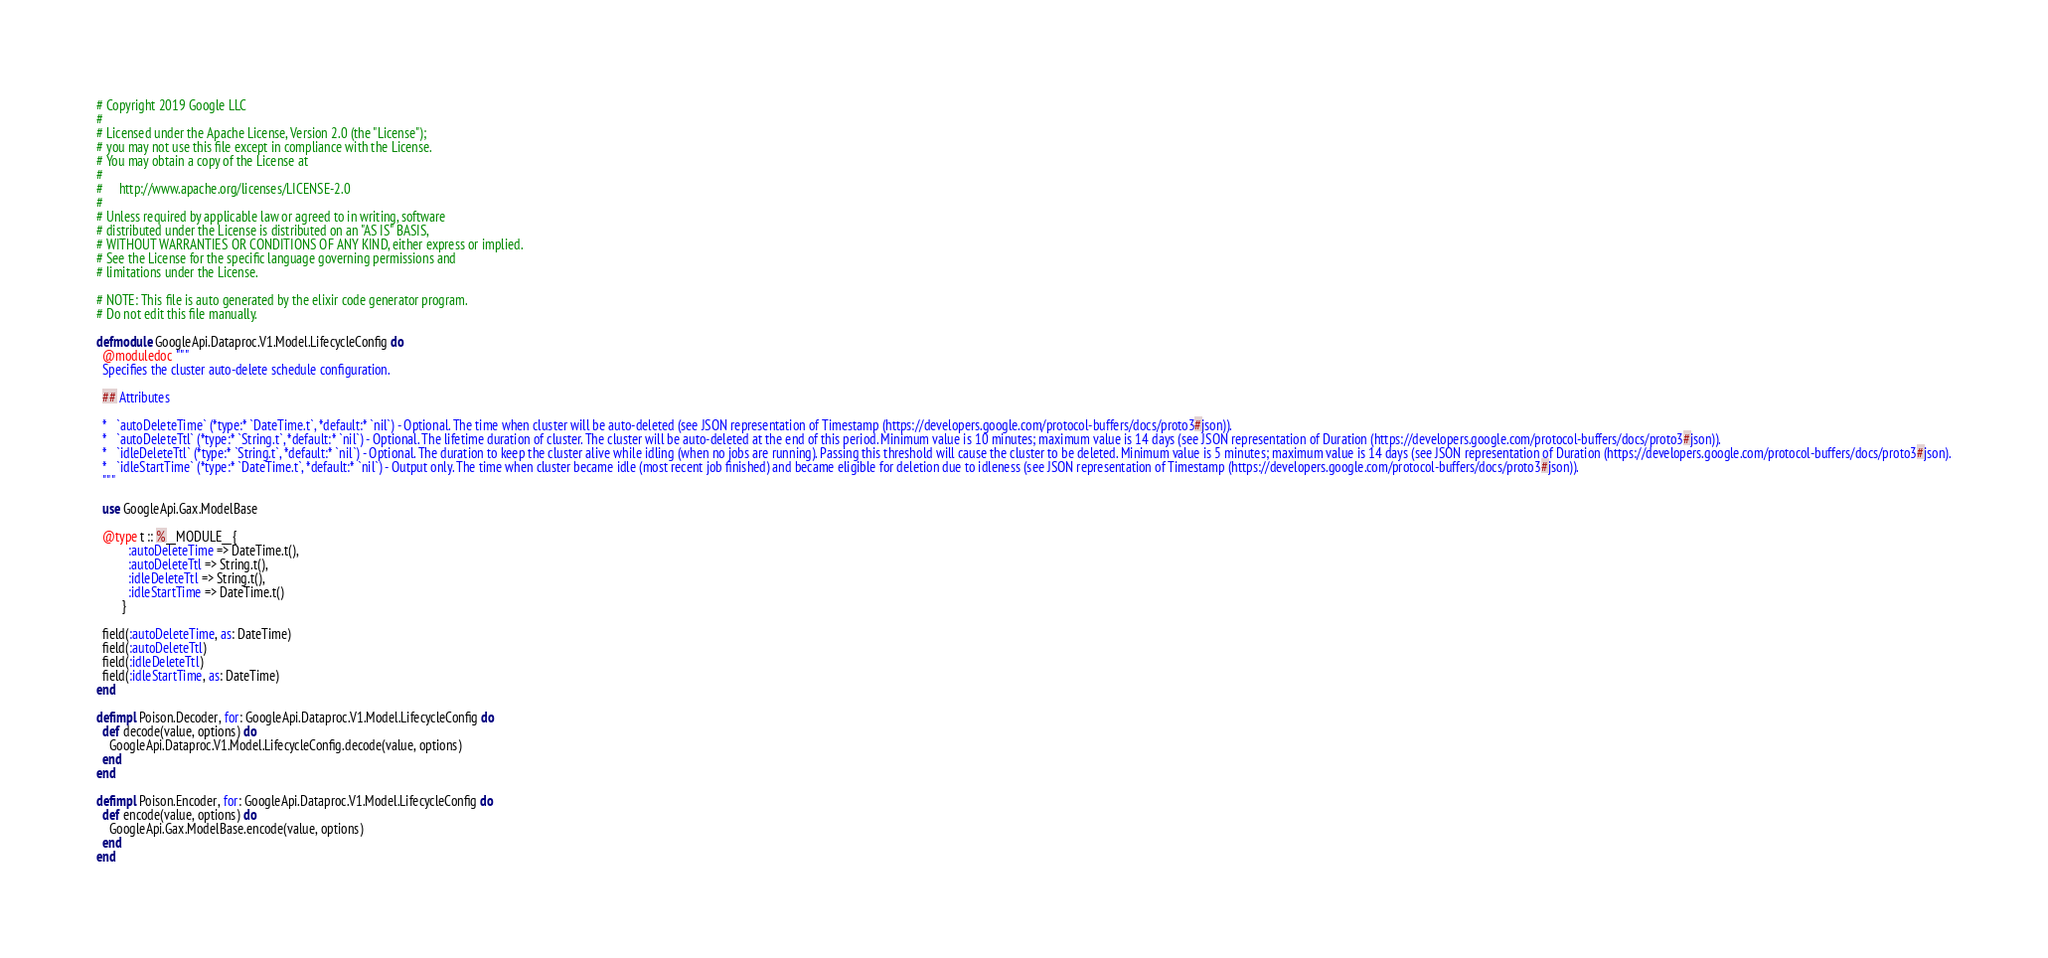Convert code to text. <code><loc_0><loc_0><loc_500><loc_500><_Elixir_># Copyright 2019 Google LLC
#
# Licensed under the Apache License, Version 2.0 (the "License");
# you may not use this file except in compliance with the License.
# You may obtain a copy of the License at
#
#     http://www.apache.org/licenses/LICENSE-2.0
#
# Unless required by applicable law or agreed to in writing, software
# distributed under the License is distributed on an "AS IS" BASIS,
# WITHOUT WARRANTIES OR CONDITIONS OF ANY KIND, either express or implied.
# See the License for the specific language governing permissions and
# limitations under the License.

# NOTE: This file is auto generated by the elixir code generator program.
# Do not edit this file manually.

defmodule GoogleApi.Dataproc.V1.Model.LifecycleConfig do
  @moduledoc """
  Specifies the cluster auto-delete schedule configuration.

  ## Attributes

  *   `autoDeleteTime` (*type:* `DateTime.t`, *default:* `nil`) - Optional. The time when cluster will be auto-deleted (see JSON representation of Timestamp (https://developers.google.com/protocol-buffers/docs/proto3#json)).
  *   `autoDeleteTtl` (*type:* `String.t`, *default:* `nil`) - Optional. The lifetime duration of cluster. The cluster will be auto-deleted at the end of this period. Minimum value is 10 minutes; maximum value is 14 days (see JSON representation of Duration (https://developers.google.com/protocol-buffers/docs/proto3#json)).
  *   `idleDeleteTtl` (*type:* `String.t`, *default:* `nil`) - Optional. The duration to keep the cluster alive while idling (when no jobs are running). Passing this threshold will cause the cluster to be deleted. Minimum value is 5 minutes; maximum value is 14 days (see JSON representation of Duration (https://developers.google.com/protocol-buffers/docs/proto3#json).
  *   `idleStartTime` (*type:* `DateTime.t`, *default:* `nil`) - Output only. The time when cluster became idle (most recent job finished) and became eligible for deletion due to idleness (see JSON representation of Timestamp (https://developers.google.com/protocol-buffers/docs/proto3#json)).
  """

  use GoogleApi.Gax.ModelBase

  @type t :: %__MODULE__{
          :autoDeleteTime => DateTime.t(),
          :autoDeleteTtl => String.t(),
          :idleDeleteTtl => String.t(),
          :idleStartTime => DateTime.t()
        }

  field(:autoDeleteTime, as: DateTime)
  field(:autoDeleteTtl)
  field(:idleDeleteTtl)
  field(:idleStartTime, as: DateTime)
end

defimpl Poison.Decoder, for: GoogleApi.Dataproc.V1.Model.LifecycleConfig do
  def decode(value, options) do
    GoogleApi.Dataproc.V1.Model.LifecycleConfig.decode(value, options)
  end
end

defimpl Poison.Encoder, for: GoogleApi.Dataproc.V1.Model.LifecycleConfig do
  def encode(value, options) do
    GoogleApi.Gax.ModelBase.encode(value, options)
  end
end
</code> 